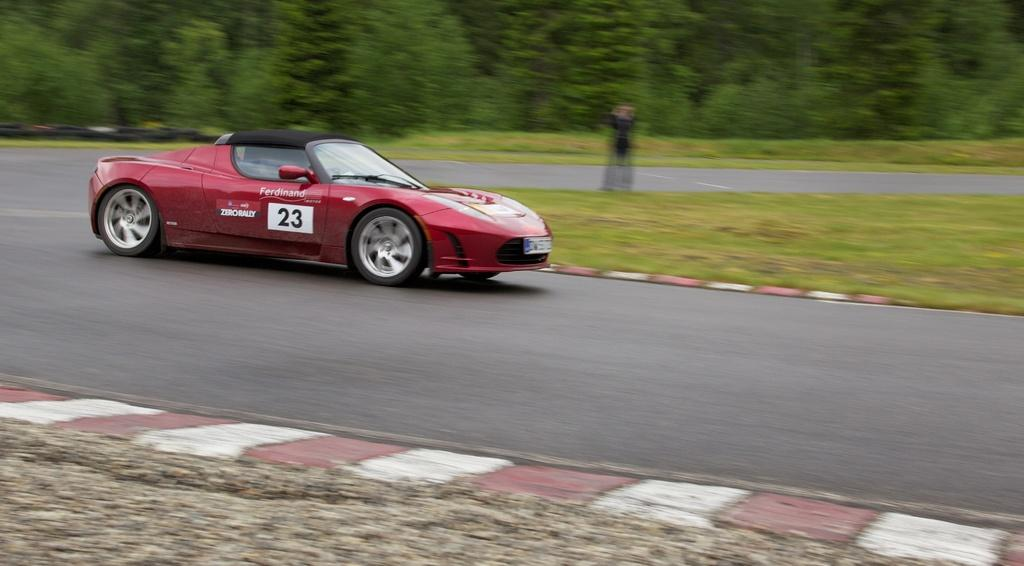What is the main subject of the image? The main subject of the image is a car. Where is the car located in the image? The car is on the road in the image. What is the color of the car? The car is red in color. Is there any text or writing on the car? Yes, there is text or writing on the car. What can be seen in the background of the image? There are many trees in the background of the image. What type of education does the car's daughter receive in the image? There is no mention of a daughter or education in the image; it features a red car on the road with text or writing on it and many trees in the background. 